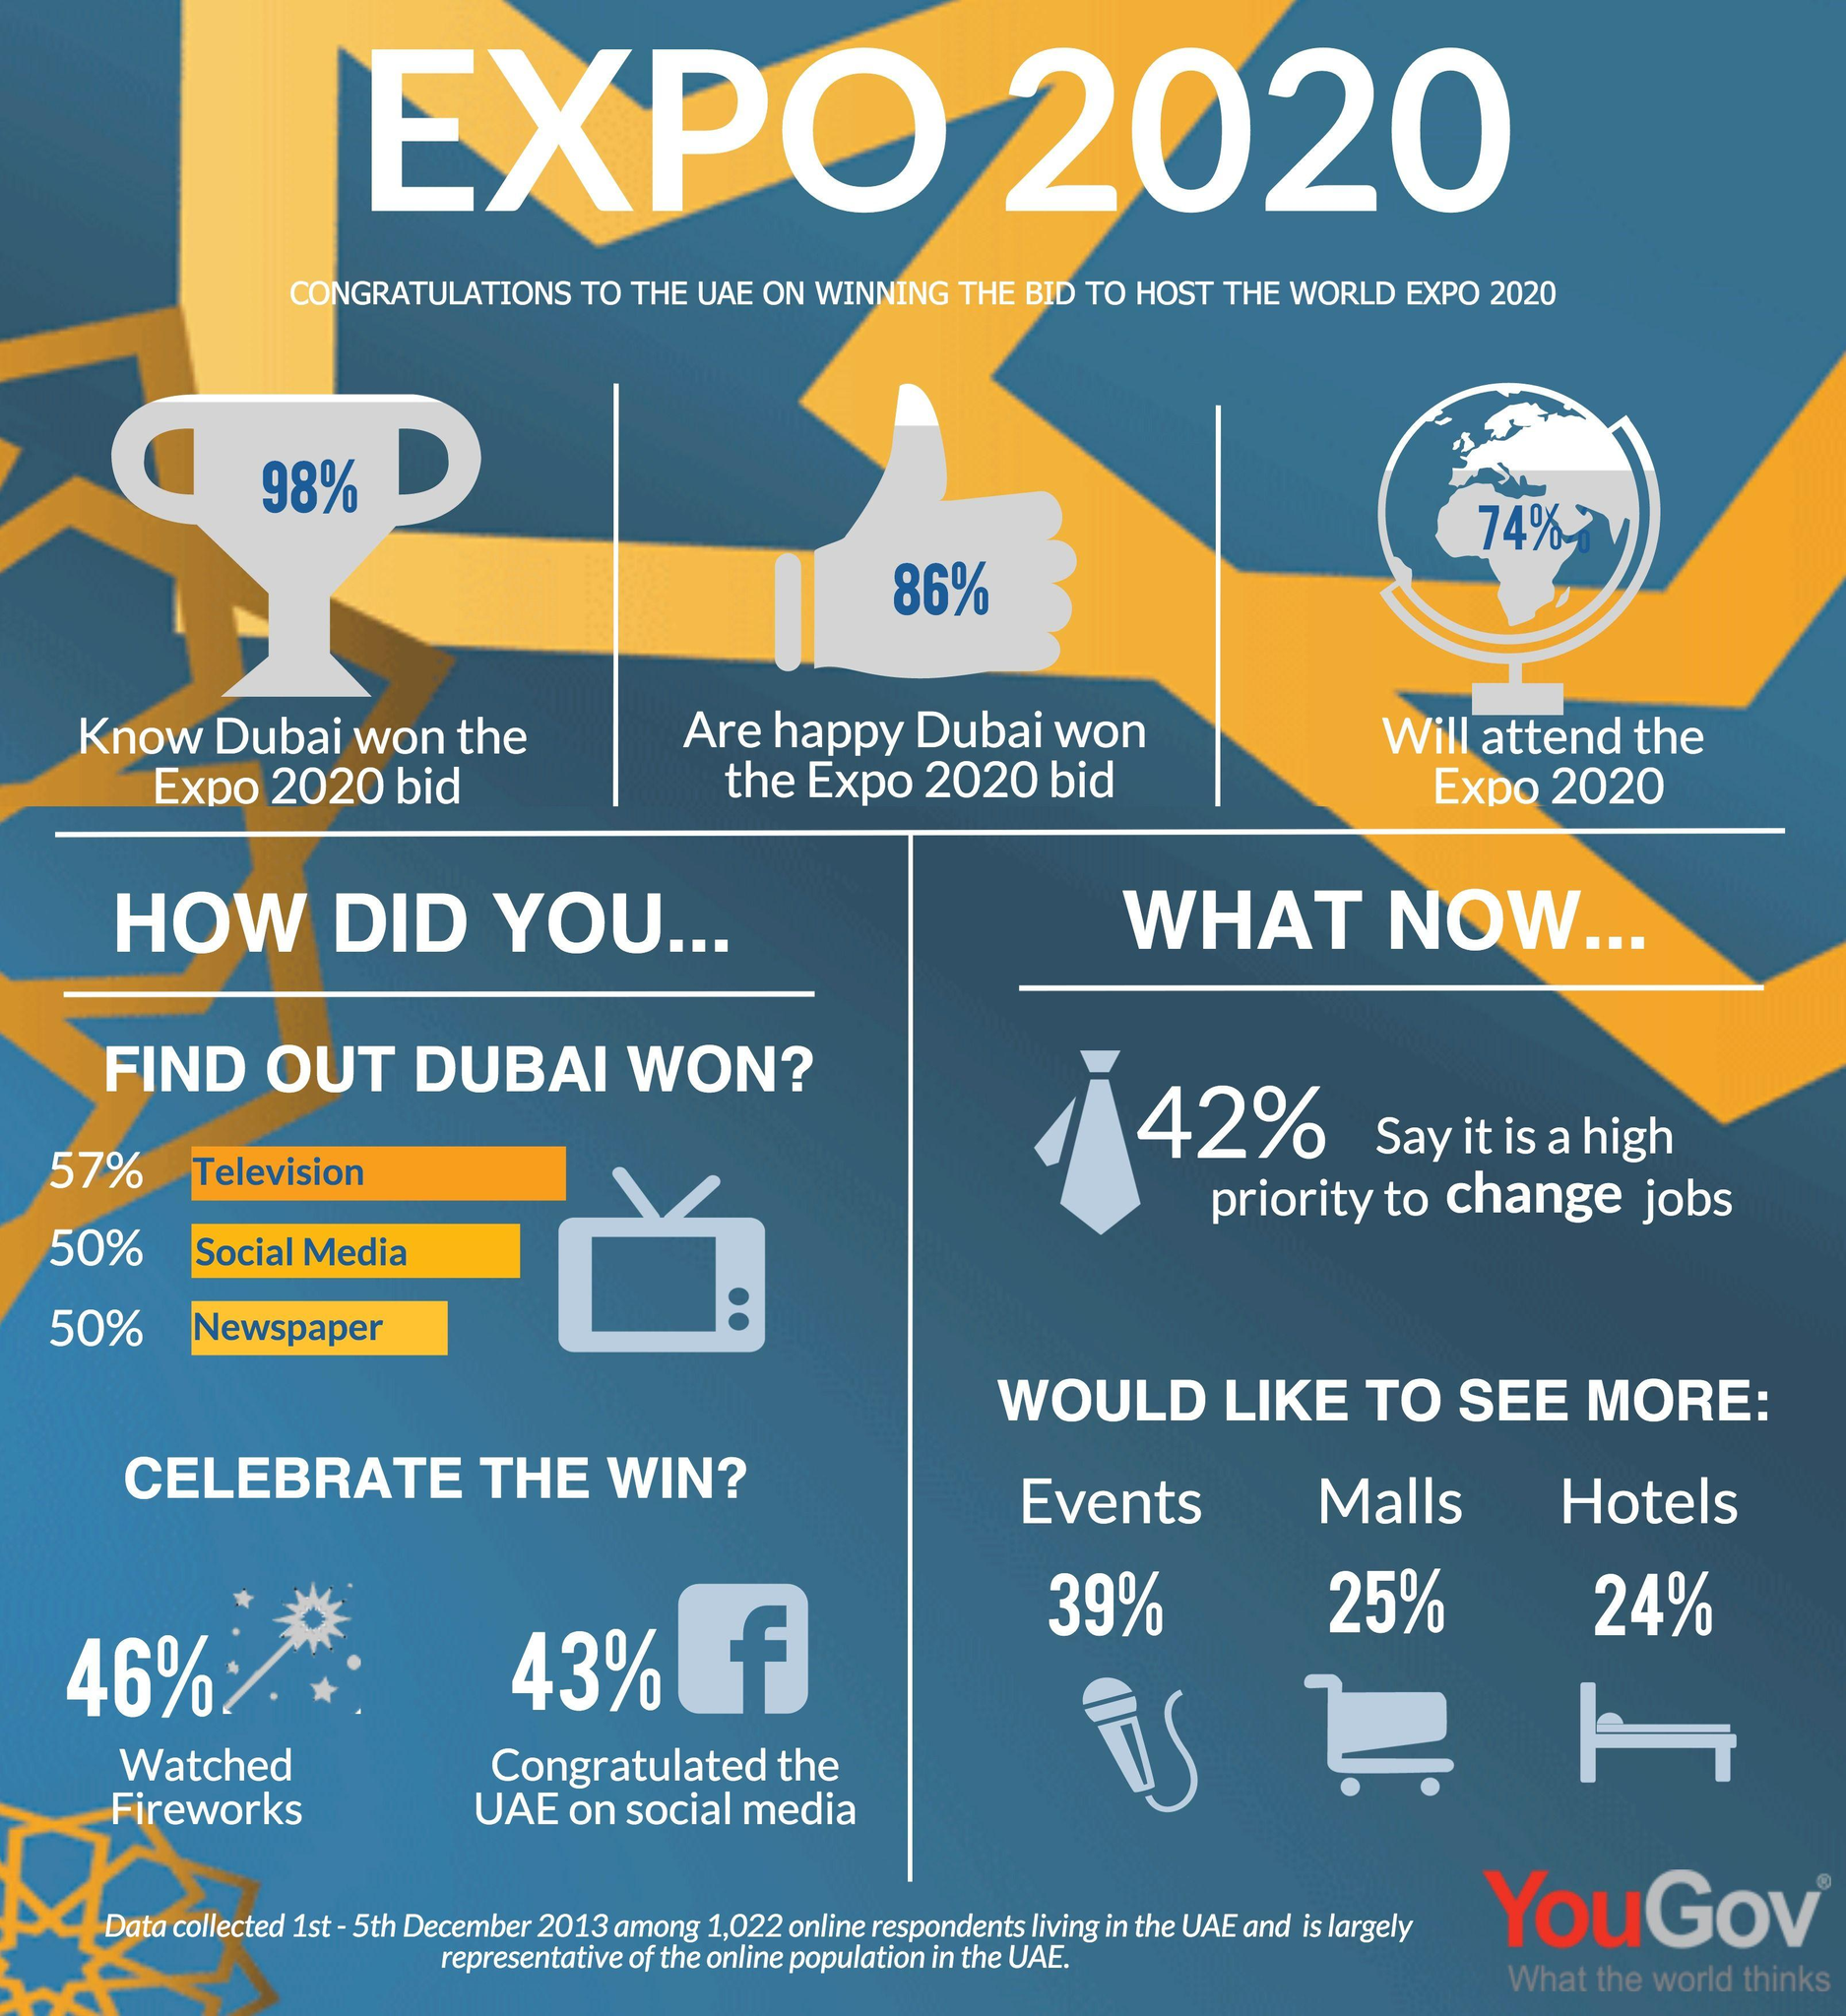Point out several critical features in this image. It is estimated that 74% of people surveyed said that they will attend the Expo 2020. It is clear that 86% of people feel joyful and elated about Dubai winning the bid. Forty-six percent of the people celebrated the win by watching fireworks. Approximately 43% of people congratulated the UAE on social media following the launch of the UAE Centennial Celebration. It is estimated that 98% of the people were aware that Dubai won the Expo 2020 bid. 